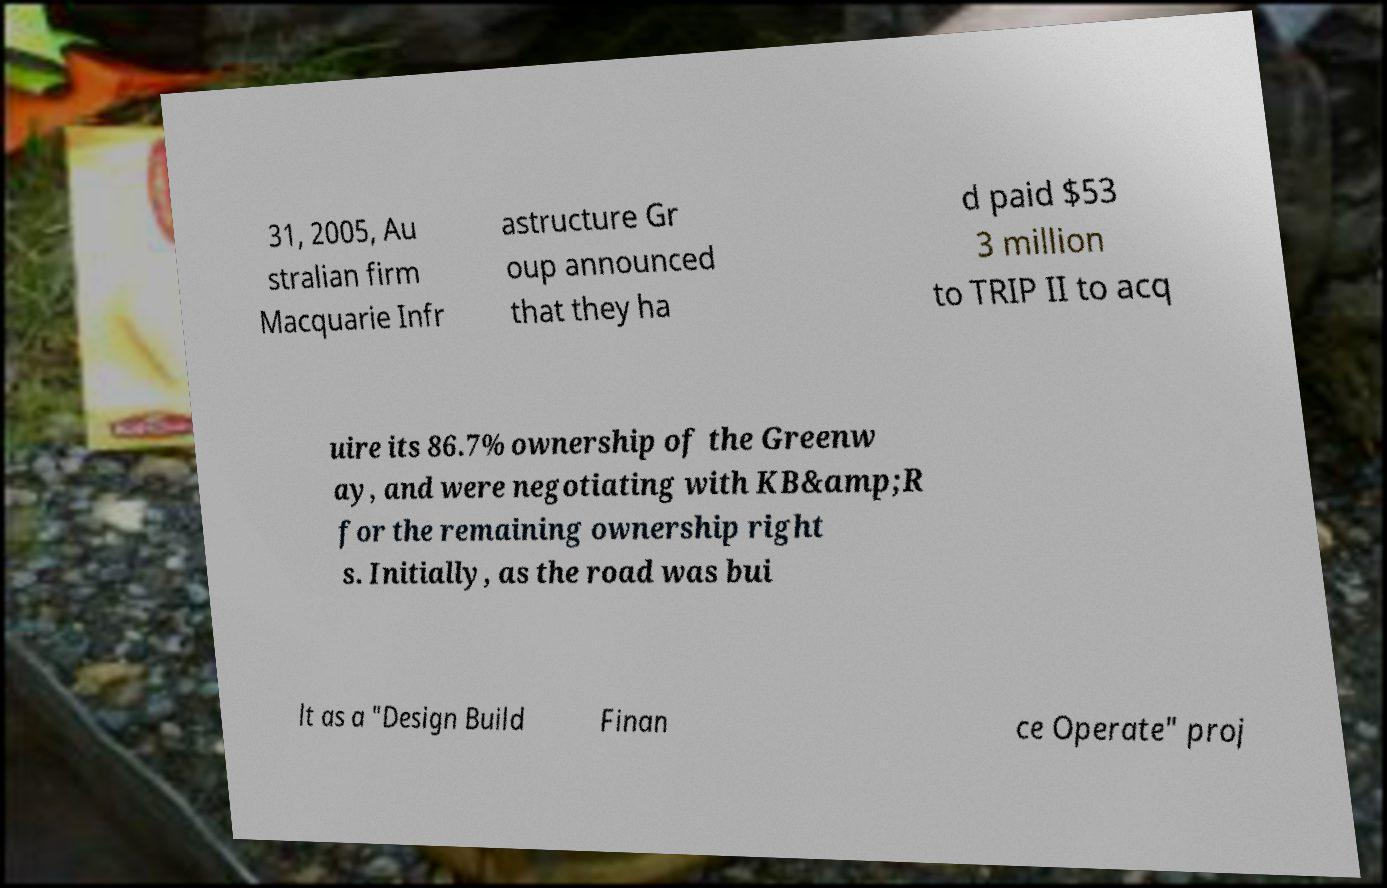What messages or text are displayed in this image? I need them in a readable, typed format. 31, 2005, Au stralian firm Macquarie Infr astructure Gr oup announced that they ha d paid $53 3 million to TRIP II to acq uire its 86.7% ownership of the Greenw ay, and were negotiating with KB&amp;R for the remaining ownership right s. Initially, as the road was bui lt as a "Design Build Finan ce Operate" proj 